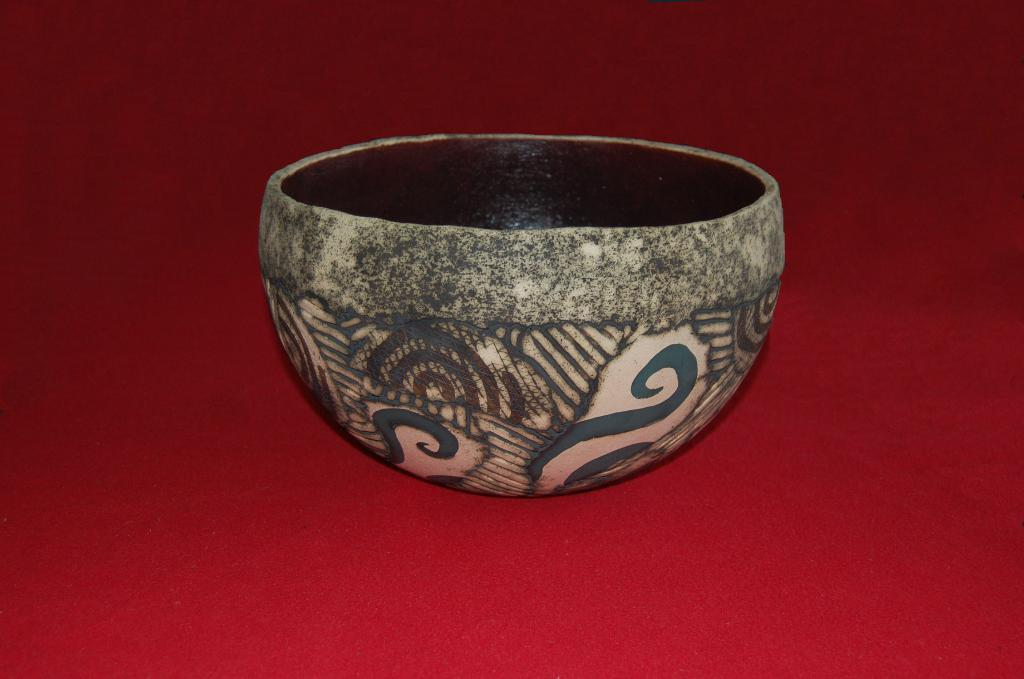What is present in the image? There is a bowl in the image. What can be observed about the surface beneath the bowl? The surface beneath the bowl is red in color. Is there a squirrel sitting on a hook in the shop in the image? There is no squirrel, hook, or shop present in the image. 